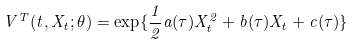<formula> <loc_0><loc_0><loc_500><loc_500>V ^ { T } ( t , X _ { t } ; \theta ) = \exp \{ \frac { 1 } { 2 } a ( \tau ) X _ { t } ^ { 2 } + b ( \tau ) X _ { t } + c ( \tau ) \}</formula> 